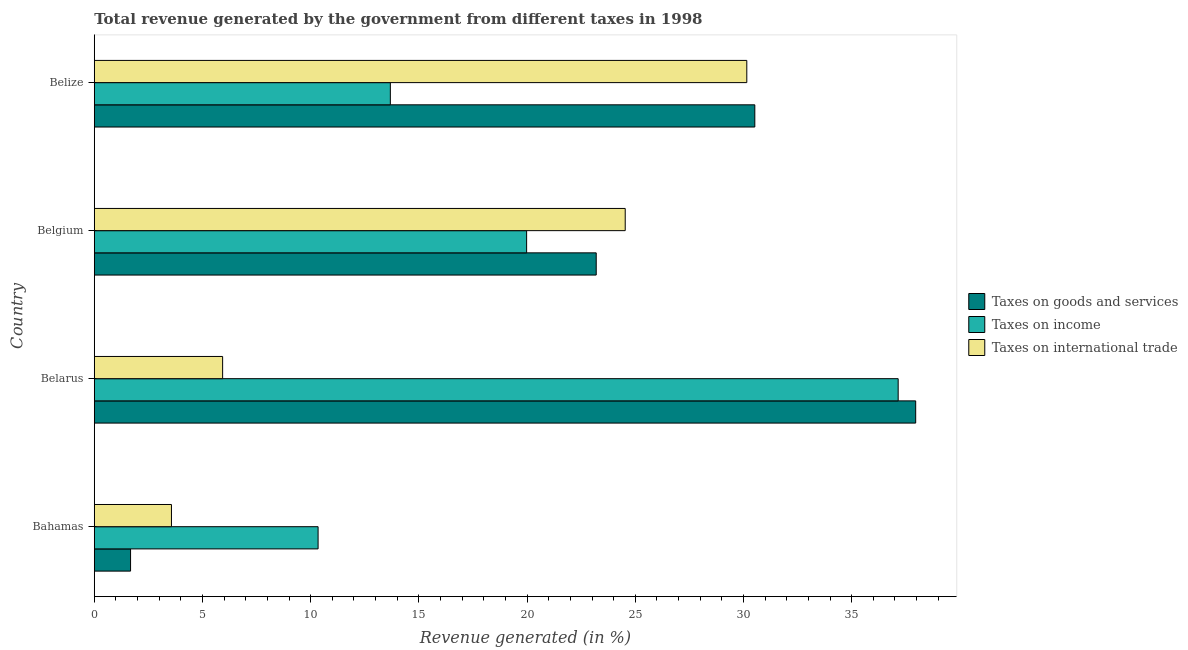How many different coloured bars are there?
Give a very brief answer. 3. How many groups of bars are there?
Provide a short and direct response. 4. Are the number of bars per tick equal to the number of legend labels?
Offer a very short reply. Yes. What is the percentage of revenue generated by taxes on income in Belgium?
Offer a terse response. 19.98. Across all countries, what is the maximum percentage of revenue generated by tax on international trade?
Provide a short and direct response. 30.15. Across all countries, what is the minimum percentage of revenue generated by taxes on income?
Provide a short and direct response. 10.34. In which country was the percentage of revenue generated by taxes on goods and services maximum?
Provide a short and direct response. Belarus. In which country was the percentage of revenue generated by tax on international trade minimum?
Keep it short and to the point. Bahamas. What is the total percentage of revenue generated by tax on international trade in the graph?
Offer a very short reply. 64.19. What is the difference between the percentage of revenue generated by taxes on income in Bahamas and that in Belize?
Your answer should be very brief. -3.34. What is the difference between the percentage of revenue generated by taxes on income in Belgium and the percentage of revenue generated by tax on international trade in Belarus?
Your response must be concise. 14.05. What is the average percentage of revenue generated by tax on international trade per country?
Offer a very short reply. 16.05. What is the difference between the percentage of revenue generated by taxes on goods and services and percentage of revenue generated by tax on international trade in Belarus?
Provide a short and direct response. 32.03. What is the ratio of the percentage of revenue generated by taxes on income in Bahamas to that in Belgium?
Provide a short and direct response. 0.52. Is the percentage of revenue generated by taxes on income in Belarus less than that in Belgium?
Offer a very short reply. No. What is the difference between the highest and the second highest percentage of revenue generated by tax on international trade?
Provide a succinct answer. 5.62. What is the difference between the highest and the lowest percentage of revenue generated by tax on international trade?
Make the answer very short. 26.59. What does the 3rd bar from the top in Belarus represents?
Ensure brevity in your answer.  Taxes on goods and services. What does the 2nd bar from the bottom in Belgium represents?
Give a very brief answer. Taxes on income. Is it the case that in every country, the sum of the percentage of revenue generated by taxes on goods and services and percentage of revenue generated by taxes on income is greater than the percentage of revenue generated by tax on international trade?
Give a very brief answer. Yes. Does the graph contain grids?
Make the answer very short. No. Where does the legend appear in the graph?
Ensure brevity in your answer.  Center right. What is the title of the graph?
Offer a terse response. Total revenue generated by the government from different taxes in 1998. What is the label or title of the X-axis?
Offer a terse response. Revenue generated (in %). What is the label or title of the Y-axis?
Your answer should be very brief. Country. What is the Revenue generated (in %) of Taxes on goods and services in Bahamas?
Give a very brief answer. 1.68. What is the Revenue generated (in %) of Taxes on income in Bahamas?
Provide a short and direct response. 10.34. What is the Revenue generated (in %) in Taxes on international trade in Bahamas?
Your answer should be compact. 3.57. What is the Revenue generated (in %) of Taxes on goods and services in Belarus?
Provide a short and direct response. 37.96. What is the Revenue generated (in %) in Taxes on income in Belarus?
Offer a very short reply. 37.15. What is the Revenue generated (in %) in Taxes on international trade in Belarus?
Offer a very short reply. 5.93. What is the Revenue generated (in %) in Taxes on goods and services in Belgium?
Your answer should be compact. 23.2. What is the Revenue generated (in %) in Taxes on income in Belgium?
Your response must be concise. 19.98. What is the Revenue generated (in %) of Taxes on international trade in Belgium?
Keep it short and to the point. 24.54. What is the Revenue generated (in %) of Taxes on goods and services in Belize?
Your answer should be very brief. 30.52. What is the Revenue generated (in %) in Taxes on income in Belize?
Ensure brevity in your answer.  13.68. What is the Revenue generated (in %) of Taxes on international trade in Belize?
Your answer should be compact. 30.15. Across all countries, what is the maximum Revenue generated (in %) in Taxes on goods and services?
Keep it short and to the point. 37.96. Across all countries, what is the maximum Revenue generated (in %) in Taxes on income?
Your response must be concise. 37.15. Across all countries, what is the maximum Revenue generated (in %) of Taxes on international trade?
Provide a succinct answer. 30.15. Across all countries, what is the minimum Revenue generated (in %) of Taxes on goods and services?
Provide a succinct answer. 1.68. Across all countries, what is the minimum Revenue generated (in %) in Taxes on income?
Keep it short and to the point. 10.34. Across all countries, what is the minimum Revenue generated (in %) in Taxes on international trade?
Keep it short and to the point. 3.57. What is the total Revenue generated (in %) in Taxes on goods and services in the graph?
Your answer should be compact. 93.35. What is the total Revenue generated (in %) in Taxes on income in the graph?
Your response must be concise. 81.15. What is the total Revenue generated (in %) of Taxes on international trade in the graph?
Ensure brevity in your answer.  64.19. What is the difference between the Revenue generated (in %) in Taxes on goods and services in Bahamas and that in Belarus?
Give a very brief answer. -36.28. What is the difference between the Revenue generated (in %) of Taxes on income in Bahamas and that in Belarus?
Ensure brevity in your answer.  -26.81. What is the difference between the Revenue generated (in %) in Taxes on international trade in Bahamas and that in Belarus?
Provide a short and direct response. -2.36. What is the difference between the Revenue generated (in %) of Taxes on goods and services in Bahamas and that in Belgium?
Your response must be concise. -21.52. What is the difference between the Revenue generated (in %) in Taxes on income in Bahamas and that in Belgium?
Offer a terse response. -9.64. What is the difference between the Revenue generated (in %) in Taxes on international trade in Bahamas and that in Belgium?
Offer a very short reply. -20.97. What is the difference between the Revenue generated (in %) of Taxes on goods and services in Bahamas and that in Belize?
Keep it short and to the point. -28.85. What is the difference between the Revenue generated (in %) of Taxes on income in Bahamas and that in Belize?
Your answer should be very brief. -3.34. What is the difference between the Revenue generated (in %) of Taxes on international trade in Bahamas and that in Belize?
Your answer should be very brief. -26.59. What is the difference between the Revenue generated (in %) of Taxes on goods and services in Belarus and that in Belgium?
Offer a very short reply. 14.76. What is the difference between the Revenue generated (in %) in Taxes on income in Belarus and that in Belgium?
Make the answer very short. 17.17. What is the difference between the Revenue generated (in %) in Taxes on international trade in Belarus and that in Belgium?
Provide a succinct answer. -18.6. What is the difference between the Revenue generated (in %) of Taxes on goods and services in Belarus and that in Belize?
Provide a short and direct response. 7.43. What is the difference between the Revenue generated (in %) in Taxes on income in Belarus and that in Belize?
Provide a succinct answer. 23.47. What is the difference between the Revenue generated (in %) of Taxes on international trade in Belarus and that in Belize?
Offer a terse response. -24.22. What is the difference between the Revenue generated (in %) in Taxes on goods and services in Belgium and that in Belize?
Your response must be concise. -7.33. What is the difference between the Revenue generated (in %) in Taxes on income in Belgium and that in Belize?
Your response must be concise. 6.3. What is the difference between the Revenue generated (in %) of Taxes on international trade in Belgium and that in Belize?
Provide a short and direct response. -5.62. What is the difference between the Revenue generated (in %) in Taxes on goods and services in Bahamas and the Revenue generated (in %) in Taxes on income in Belarus?
Your response must be concise. -35.47. What is the difference between the Revenue generated (in %) in Taxes on goods and services in Bahamas and the Revenue generated (in %) in Taxes on international trade in Belarus?
Your answer should be very brief. -4.25. What is the difference between the Revenue generated (in %) in Taxes on income in Bahamas and the Revenue generated (in %) in Taxes on international trade in Belarus?
Keep it short and to the point. 4.41. What is the difference between the Revenue generated (in %) in Taxes on goods and services in Bahamas and the Revenue generated (in %) in Taxes on income in Belgium?
Ensure brevity in your answer.  -18.3. What is the difference between the Revenue generated (in %) in Taxes on goods and services in Bahamas and the Revenue generated (in %) in Taxes on international trade in Belgium?
Make the answer very short. -22.86. What is the difference between the Revenue generated (in %) of Taxes on income in Bahamas and the Revenue generated (in %) of Taxes on international trade in Belgium?
Provide a short and direct response. -14.19. What is the difference between the Revenue generated (in %) of Taxes on goods and services in Bahamas and the Revenue generated (in %) of Taxes on income in Belize?
Offer a very short reply. -12.01. What is the difference between the Revenue generated (in %) of Taxes on goods and services in Bahamas and the Revenue generated (in %) of Taxes on international trade in Belize?
Keep it short and to the point. -28.48. What is the difference between the Revenue generated (in %) in Taxes on income in Bahamas and the Revenue generated (in %) in Taxes on international trade in Belize?
Ensure brevity in your answer.  -19.81. What is the difference between the Revenue generated (in %) in Taxes on goods and services in Belarus and the Revenue generated (in %) in Taxes on income in Belgium?
Give a very brief answer. 17.98. What is the difference between the Revenue generated (in %) in Taxes on goods and services in Belarus and the Revenue generated (in %) in Taxes on international trade in Belgium?
Ensure brevity in your answer.  13.42. What is the difference between the Revenue generated (in %) of Taxes on income in Belarus and the Revenue generated (in %) of Taxes on international trade in Belgium?
Provide a succinct answer. 12.61. What is the difference between the Revenue generated (in %) of Taxes on goods and services in Belarus and the Revenue generated (in %) of Taxes on income in Belize?
Your response must be concise. 24.28. What is the difference between the Revenue generated (in %) of Taxes on goods and services in Belarus and the Revenue generated (in %) of Taxes on international trade in Belize?
Provide a succinct answer. 7.8. What is the difference between the Revenue generated (in %) of Taxes on income in Belarus and the Revenue generated (in %) of Taxes on international trade in Belize?
Offer a terse response. 7. What is the difference between the Revenue generated (in %) of Taxes on goods and services in Belgium and the Revenue generated (in %) of Taxes on income in Belize?
Make the answer very short. 9.51. What is the difference between the Revenue generated (in %) of Taxes on goods and services in Belgium and the Revenue generated (in %) of Taxes on international trade in Belize?
Give a very brief answer. -6.96. What is the difference between the Revenue generated (in %) of Taxes on income in Belgium and the Revenue generated (in %) of Taxes on international trade in Belize?
Ensure brevity in your answer.  -10.17. What is the average Revenue generated (in %) in Taxes on goods and services per country?
Your answer should be compact. 23.34. What is the average Revenue generated (in %) of Taxes on income per country?
Your answer should be very brief. 20.29. What is the average Revenue generated (in %) in Taxes on international trade per country?
Your answer should be compact. 16.05. What is the difference between the Revenue generated (in %) of Taxes on goods and services and Revenue generated (in %) of Taxes on income in Bahamas?
Provide a succinct answer. -8.67. What is the difference between the Revenue generated (in %) in Taxes on goods and services and Revenue generated (in %) in Taxes on international trade in Bahamas?
Make the answer very short. -1.89. What is the difference between the Revenue generated (in %) of Taxes on income and Revenue generated (in %) of Taxes on international trade in Bahamas?
Give a very brief answer. 6.78. What is the difference between the Revenue generated (in %) of Taxes on goods and services and Revenue generated (in %) of Taxes on income in Belarus?
Your answer should be very brief. 0.81. What is the difference between the Revenue generated (in %) in Taxes on goods and services and Revenue generated (in %) in Taxes on international trade in Belarus?
Provide a short and direct response. 32.03. What is the difference between the Revenue generated (in %) of Taxes on income and Revenue generated (in %) of Taxes on international trade in Belarus?
Keep it short and to the point. 31.22. What is the difference between the Revenue generated (in %) of Taxes on goods and services and Revenue generated (in %) of Taxes on income in Belgium?
Offer a terse response. 3.22. What is the difference between the Revenue generated (in %) of Taxes on goods and services and Revenue generated (in %) of Taxes on international trade in Belgium?
Ensure brevity in your answer.  -1.34. What is the difference between the Revenue generated (in %) of Taxes on income and Revenue generated (in %) of Taxes on international trade in Belgium?
Your response must be concise. -4.56. What is the difference between the Revenue generated (in %) in Taxes on goods and services and Revenue generated (in %) in Taxes on income in Belize?
Keep it short and to the point. 16.84. What is the difference between the Revenue generated (in %) of Taxes on goods and services and Revenue generated (in %) of Taxes on international trade in Belize?
Keep it short and to the point. 0.37. What is the difference between the Revenue generated (in %) of Taxes on income and Revenue generated (in %) of Taxes on international trade in Belize?
Your answer should be compact. -16.47. What is the ratio of the Revenue generated (in %) of Taxes on goods and services in Bahamas to that in Belarus?
Your answer should be compact. 0.04. What is the ratio of the Revenue generated (in %) of Taxes on income in Bahamas to that in Belarus?
Make the answer very short. 0.28. What is the ratio of the Revenue generated (in %) of Taxes on international trade in Bahamas to that in Belarus?
Offer a very short reply. 0.6. What is the ratio of the Revenue generated (in %) in Taxes on goods and services in Bahamas to that in Belgium?
Your answer should be compact. 0.07. What is the ratio of the Revenue generated (in %) of Taxes on income in Bahamas to that in Belgium?
Your answer should be very brief. 0.52. What is the ratio of the Revenue generated (in %) of Taxes on international trade in Bahamas to that in Belgium?
Your response must be concise. 0.15. What is the ratio of the Revenue generated (in %) in Taxes on goods and services in Bahamas to that in Belize?
Your response must be concise. 0.05. What is the ratio of the Revenue generated (in %) in Taxes on income in Bahamas to that in Belize?
Your answer should be very brief. 0.76. What is the ratio of the Revenue generated (in %) of Taxes on international trade in Bahamas to that in Belize?
Keep it short and to the point. 0.12. What is the ratio of the Revenue generated (in %) of Taxes on goods and services in Belarus to that in Belgium?
Your answer should be compact. 1.64. What is the ratio of the Revenue generated (in %) in Taxes on income in Belarus to that in Belgium?
Your answer should be compact. 1.86. What is the ratio of the Revenue generated (in %) of Taxes on international trade in Belarus to that in Belgium?
Provide a short and direct response. 0.24. What is the ratio of the Revenue generated (in %) of Taxes on goods and services in Belarus to that in Belize?
Provide a succinct answer. 1.24. What is the ratio of the Revenue generated (in %) of Taxes on income in Belarus to that in Belize?
Ensure brevity in your answer.  2.72. What is the ratio of the Revenue generated (in %) of Taxes on international trade in Belarus to that in Belize?
Provide a succinct answer. 0.2. What is the ratio of the Revenue generated (in %) of Taxes on goods and services in Belgium to that in Belize?
Offer a terse response. 0.76. What is the ratio of the Revenue generated (in %) in Taxes on income in Belgium to that in Belize?
Provide a short and direct response. 1.46. What is the ratio of the Revenue generated (in %) in Taxes on international trade in Belgium to that in Belize?
Ensure brevity in your answer.  0.81. What is the difference between the highest and the second highest Revenue generated (in %) in Taxes on goods and services?
Your response must be concise. 7.43. What is the difference between the highest and the second highest Revenue generated (in %) of Taxes on income?
Your answer should be compact. 17.17. What is the difference between the highest and the second highest Revenue generated (in %) in Taxes on international trade?
Give a very brief answer. 5.62. What is the difference between the highest and the lowest Revenue generated (in %) in Taxes on goods and services?
Your response must be concise. 36.28. What is the difference between the highest and the lowest Revenue generated (in %) of Taxes on income?
Provide a succinct answer. 26.81. What is the difference between the highest and the lowest Revenue generated (in %) of Taxes on international trade?
Ensure brevity in your answer.  26.59. 